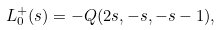Convert formula to latex. <formula><loc_0><loc_0><loc_500><loc_500>L _ { 0 } ^ { + } ( s ) = - Q ( 2 s , - s , - s - 1 ) ,</formula> 